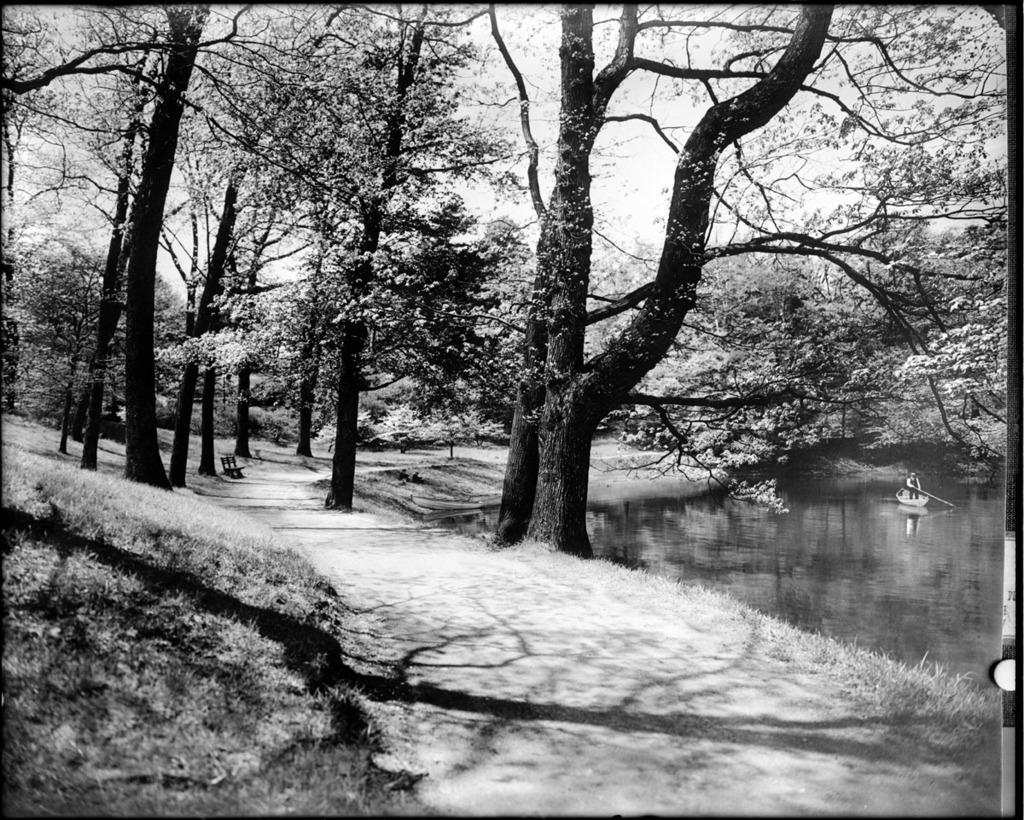What is the color scheme of the image? The image is black and white. What type of vegetation can be seen in the image? There are trees and grass in the image. What object is present for sitting in the image? There is a bench in the image. What activity is taking place on the water in the image? There is a person rowing a boat on the water in the image. What part of the natural environment is visible in the image? The sky is visible in the image. What type of animal is being fed zinc in the image? There is no animal being fed zinc in the image, as the image does not depict any animals or the act of feeding. 